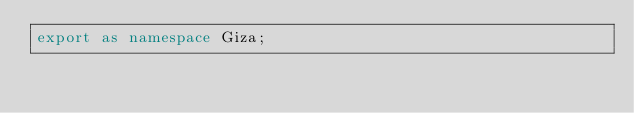<code> <loc_0><loc_0><loc_500><loc_500><_TypeScript_>export as namespace Giza;

</code> 